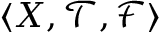<formula> <loc_0><loc_0><loc_500><loc_500>\langle X , { \mathcal { T } } , { \mathcal { F } } \rangle</formula> 